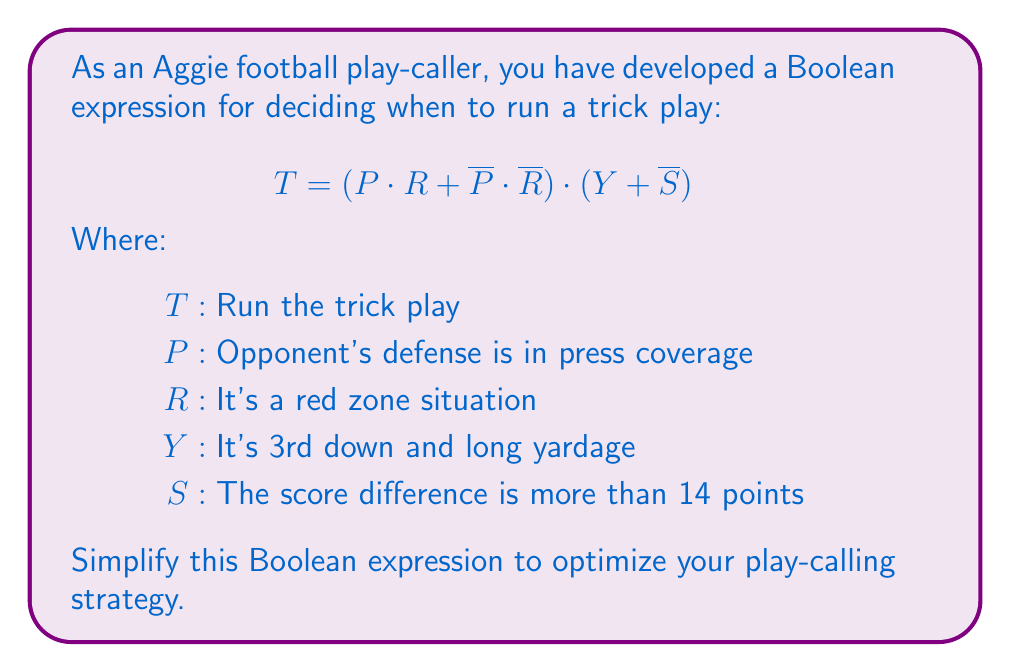Solve this math problem. Let's simplify the expression step by step:

1) First, let's focus on the part $(P \cdot R + \overline{P} \cdot \overline{R})$:
   This is in the form of $A \cdot B + \overline{A} \cdot \overline{B}$, which is equivalent to the XNOR operation.
   So, $(P \cdot R + \overline{P} \cdot \overline{R}) = P \oplus R$

2) Now our expression looks like:
   $T = (P \oplus R) \cdot (Y + \overline{S})$

3) Let's distribute $(P \oplus R)$ over $(Y + \overline{S})$:
   $T = (P \oplus R) \cdot Y + (P \oplus R) \cdot \overline{S}$

4) This is our simplified expression. We can interpret it as:
   "Run the trick play if:
   (the defense is in press coverage XOR it's a red zone situation) AND (it's 3rd and long
   OR the score difference is not more than 14 points)"

This simplification reduces the complexity of the original expression while maintaining its logical structure.
Answer: $T = (P \oplus R) \cdot Y + (P \oplus R) \cdot \overline{S}$ 